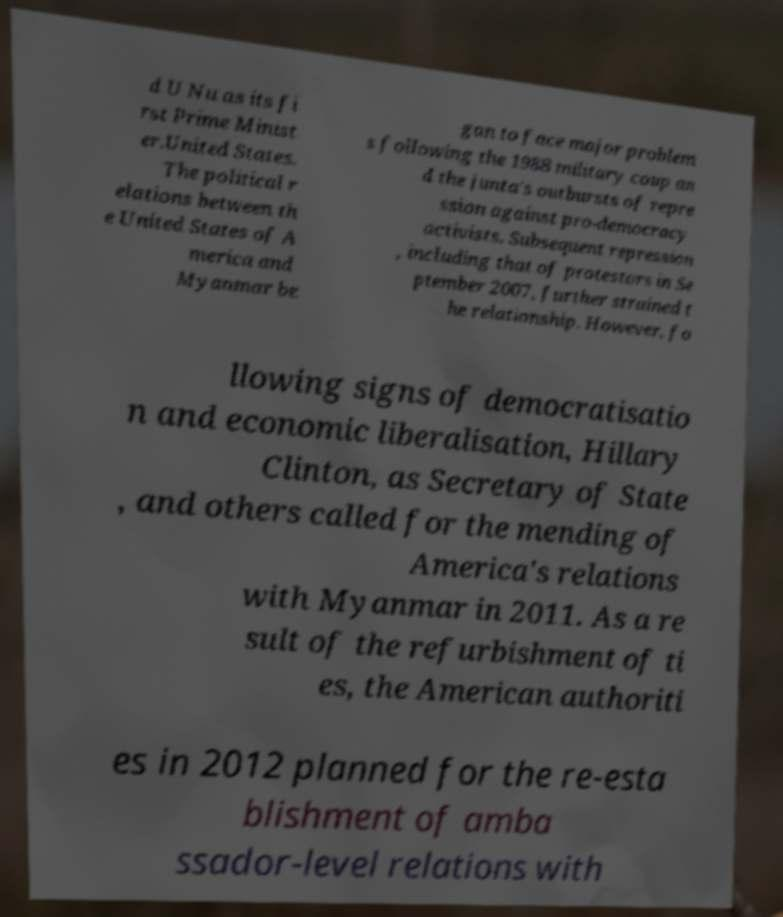Please identify and transcribe the text found in this image. d U Nu as its fi rst Prime Minist er.United States. The political r elations between th e United States of A merica and Myanmar be gan to face major problem s following the 1988 military coup an d the junta's outbursts of repre ssion against pro-democracy activists. Subsequent repression , including that of protestors in Se ptember 2007, further strained t he relationship. However, fo llowing signs of democratisatio n and economic liberalisation, Hillary Clinton, as Secretary of State , and others called for the mending of America's relations with Myanmar in 2011. As a re sult of the refurbishment of ti es, the American authoriti es in 2012 planned for the re-esta blishment of amba ssador-level relations with 